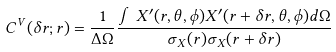Convert formula to latex. <formula><loc_0><loc_0><loc_500><loc_500>C ^ { V } ( \delta r ; r ) = \frac { 1 } { \Delta \Omega } \frac { \int X ^ { \prime } ( r , \theta , \phi ) X ^ { \prime } ( r + \delta r , \theta , \phi ) d \Omega } { \sigma _ { X } ( r ) \sigma _ { X } ( r + \delta r ) }</formula> 